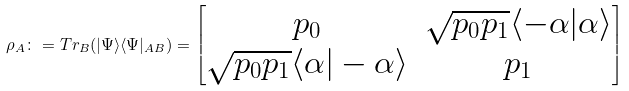<formula> <loc_0><loc_0><loc_500><loc_500>\rho _ { A } \colon = T r _ { B } ( | \Psi \rangle \langle \Psi | _ { A B } ) = \begin{bmatrix} p _ { 0 } & \sqrt { p _ { 0 } p _ { 1 } } \langle - \alpha | \alpha \rangle \\ \sqrt { p _ { 0 } p _ { 1 } } \langle \alpha | - \alpha \rangle & p _ { 1 } \end{bmatrix}</formula> 